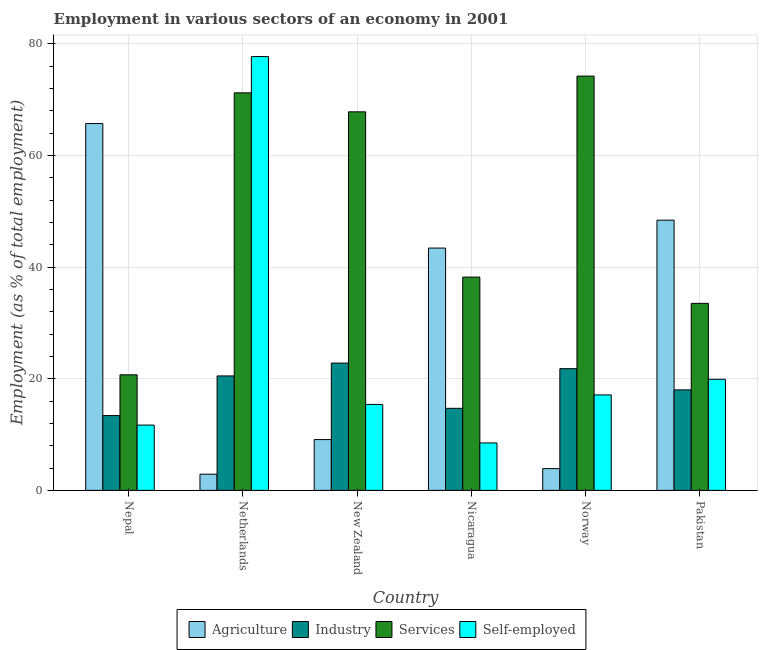How many groups of bars are there?
Make the answer very short. 6. Are the number of bars per tick equal to the number of legend labels?
Offer a very short reply. Yes. Are the number of bars on each tick of the X-axis equal?
Provide a succinct answer. Yes. How many bars are there on the 1st tick from the right?
Your response must be concise. 4. In how many cases, is the number of bars for a given country not equal to the number of legend labels?
Make the answer very short. 0. What is the percentage of workers in agriculture in Nepal?
Provide a succinct answer. 65.7. Across all countries, what is the maximum percentage of workers in agriculture?
Provide a short and direct response. 65.7. Across all countries, what is the minimum percentage of workers in agriculture?
Your response must be concise. 2.9. In which country was the percentage of workers in agriculture maximum?
Provide a short and direct response. Nepal. In which country was the percentage of workers in services minimum?
Make the answer very short. Nepal. What is the total percentage of workers in services in the graph?
Offer a terse response. 305.6. What is the difference between the percentage of workers in agriculture in Netherlands and that in Nicaragua?
Keep it short and to the point. -40.5. What is the difference between the percentage of self employed workers in Netherlands and the percentage of workers in services in Nepal?
Give a very brief answer. 57. What is the average percentage of workers in services per country?
Your response must be concise. 50.93. What is the difference between the percentage of workers in industry and percentage of workers in services in Netherlands?
Keep it short and to the point. -50.7. In how many countries, is the percentage of workers in services greater than 56 %?
Offer a very short reply. 3. What is the ratio of the percentage of workers in industry in Nepal to that in Norway?
Offer a terse response. 0.61. Is the percentage of workers in agriculture in New Zealand less than that in Norway?
Provide a short and direct response. No. Is the difference between the percentage of workers in services in Netherlands and Nicaragua greater than the difference between the percentage of workers in industry in Netherlands and Nicaragua?
Make the answer very short. Yes. What is the difference between the highest and the second highest percentage of workers in services?
Keep it short and to the point. 3. What is the difference between the highest and the lowest percentage of workers in services?
Offer a very short reply. 53.5. In how many countries, is the percentage of workers in industry greater than the average percentage of workers in industry taken over all countries?
Offer a terse response. 3. Is the sum of the percentage of workers in industry in Nepal and Nicaragua greater than the maximum percentage of self employed workers across all countries?
Your response must be concise. No. What does the 1st bar from the left in Pakistan represents?
Provide a short and direct response. Agriculture. What does the 2nd bar from the right in Norway represents?
Provide a short and direct response. Services. How many bars are there?
Offer a very short reply. 24. Does the graph contain any zero values?
Make the answer very short. No. Does the graph contain grids?
Provide a short and direct response. Yes. Where does the legend appear in the graph?
Your answer should be very brief. Bottom center. How many legend labels are there?
Provide a succinct answer. 4. What is the title of the graph?
Provide a short and direct response. Employment in various sectors of an economy in 2001. Does "Corruption" appear as one of the legend labels in the graph?
Your answer should be compact. No. What is the label or title of the X-axis?
Give a very brief answer. Country. What is the label or title of the Y-axis?
Offer a terse response. Employment (as % of total employment). What is the Employment (as % of total employment) of Agriculture in Nepal?
Make the answer very short. 65.7. What is the Employment (as % of total employment) of Industry in Nepal?
Your answer should be compact. 13.4. What is the Employment (as % of total employment) of Services in Nepal?
Make the answer very short. 20.7. What is the Employment (as % of total employment) in Self-employed in Nepal?
Provide a short and direct response. 11.7. What is the Employment (as % of total employment) of Agriculture in Netherlands?
Provide a succinct answer. 2.9. What is the Employment (as % of total employment) of Services in Netherlands?
Your answer should be very brief. 71.2. What is the Employment (as % of total employment) of Self-employed in Netherlands?
Provide a succinct answer. 77.7. What is the Employment (as % of total employment) in Agriculture in New Zealand?
Ensure brevity in your answer.  9.1. What is the Employment (as % of total employment) in Industry in New Zealand?
Offer a very short reply. 22.8. What is the Employment (as % of total employment) of Services in New Zealand?
Offer a very short reply. 67.8. What is the Employment (as % of total employment) in Self-employed in New Zealand?
Your answer should be compact. 15.4. What is the Employment (as % of total employment) in Agriculture in Nicaragua?
Your answer should be compact. 43.4. What is the Employment (as % of total employment) in Industry in Nicaragua?
Offer a very short reply. 14.7. What is the Employment (as % of total employment) in Services in Nicaragua?
Provide a short and direct response. 38.2. What is the Employment (as % of total employment) of Self-employed in Nicaragua?
Your answer should be very brief. 8.5. What is the Employment (as % of total employment) in Agriculture in Norway?
Ensure brevity in your answer.  3.9. What is the Employment (as % of total employment) in Industry in Norway?
Give a very brief answer. 21.8. What is the Employment (as % of total employment) of Services in Norway?
Give a very brief answer. 74.2. What is the Employment (as % of total employment) in Self-employed in Norway?
Ensure brevity in your answer.  17.1. What is the Employment (as % of total employment) of Agriculture in Pakistan?
Your response must be concise. 48.4. What is the Employment (as % of total employment) in Industry in Pakistan?
Keep it short and to the point. 18. What is the Employment (as % of total employment) of Services in Pakistan?
Make the answer very short. 33.5. What is the Employment (as % of total employment) of Self-employed in Pakistan?
Your response must be concise. 19.9. Across all countries, what is the maximum Employment (as % of total employment) in Agriculture?
Provide a short and direct response. 65.7. Across all countries, what is the maximum Employment (as % of total employment) in Industry?
Your answer should be compact. 22.8. Across all countries, what is the maximum Employment (as % of total employment) in Services?
Your answer should be very brief. 74.2. Across all countries, what is the maximum Employment (as % of total employment) in Self-employed?
Your answer should be compact. 77.7. Across all countries, what is the minimum Employment (as % of total employment) in Agriculture?
Your answer should be compact. 2.9. Across all countries, what is the minimum Employment (as % of total employment) in Industry?
Offer a terse response. 13.4. Across all countries, what is the minimum Employment (as % of total employment) of Services?
Ensure brevity in your answer.  20.7. Across all countries, what is the minimum Employment (as % of total employment) in Self-employed?
Give a very brief answer. 8.5. What is the total Employment (as % of total employment) in Agriculture in the graph?
Offer a terse response. 173.4. What is the total Employment (as % of total employment) of Industry in the graph?
Make the answer very short. 111.2. What is the total Employment (as % of total employment) of Services in the graph?
Your answer should be compact. 305.6. What is the total Employment (as % of total employment) in Self-employed in the graph?
Offer a terse response. 150.3. What is the difference between the Employment (as % of total employment) in Agriculture in Nepal and that in Netherlands?
Offer a terse response. 62.8. What is the difference between the Employment (as % of total employment) in Services in Nepal and that in Netherlands?
Give a very brief answer. -50.5. What is the difference between the Employment (as % of total employment) of Self-employed in Nepal and that in Netherlands?
Your response must be concise. -66. What is the difference between the Employment (as % of total employment) in Agriculture in Nepal and that in New Zealand?
Make the answer very short. 56.6. What is the difference between the Employment (as % of total employment) of Services in Nepal and that in New Zealand?
Ensure brevity in your answer.  -47.1. What is the difference between the Employment (as % of total employment) of Self-employed in Nepal and that in New Zealand?
Keep it short and to the point. -3.7. What is the difference between the Employment (as % of total employment) in Agriculture in Nepal and that in Nicaragua?
Give a very brief answer. 22.3. What is the difference between the Employment (as % of total employment) of Services in Nepal and that in Nicaragua?
Offer a very short reply. -17.5. What is the difference between the Employment (as % of total employment) of Self-employed in Nepal and that in Nicaragua?
Provide a succinct answer. 3.2. What is the difference between the Employment (as % of total employment) in Agriculture in Nepal and that in Norway?
Make the answer very short. 61.8. What is the difference between the Employment (as % of total employment) of Services in Nepal and that in Norway?
Make the answer very short. -53.5. What is the difference between the Employment (as % of total employment) in Self-employed in Nepal and that in Norway?
Offer a very short reply. -5.4. What is the difference between the Employment (as % of total employment) of Industry in Nepal and that in Pakistan?
Your response must be concise. -4.6. What is the difference between the Employment (as % of total employment) in Services in Nepal and that in Pakistan?
Your answer should be very brief. -12.8. What is the difference between the Employment (as % of total employment) in Self-employed in Nepal and that in Pakistan?
Offer a very short reply. -8.2. What is the difference between the Employment (as % of total employment) in Agriculture in Netherlands and that in New Zealand?
Your answer should be compact. -6.2. What is the difference between the Employment (as % of total employment) in Industry in Netherlands and that in New Zealand?
Keep it short and to the point. -2.3. What is the difference between the Employment (as % of total employment) of Self-employed in Netherlands and that in New Zealand?
Make the answer very short. 62.3. What is the difference between the Employment (as % of total employment) in Agriculture in Netherlands and that in Nicaragua?
Offer a terse response. -40.5. What is the difference between the Employment (as % of total employment) in Self-employed in Netherlands and that in Nicaragua?
Your response must be concise. 69.2. What is the difference between the Employment (as % of total employment) in Self-employed in Netherlands and that in Norway?
Provide a succinct answer. 60.6. What is the difference between the Employment (as % of total employment) of Agriculture in Netherlands and that in Pakistan?
Offer a very short reply. -45.5. What is the difference between the Employment (as % of total employment) in Industry in Netherlands and that in Pakistan?
Your answer should be compact. 2.5. What is the difference between the Employment (as % of total employment) of Services in Netherlands and that in Pakistan?
Offer a very short reply. 37.7. What is the difference between the Employment (as % of total employment) of Self-employed in Netherlands and that in Pakistan?
Give a very brief answer. 57.8. What is the difference between the Employment (as % of total employment) of Agriculture in New Zealand and that in Nicaragua?
Ensure brevity in your answer.  -34.3. What is the difference between the Employment (as % of total employment) in Industry in New Zealand and that in Nicaragua?
Keep it short and to the point. 8.1. What is the difference between the Employment (as % of total employment) of Services in New Zealand and that in Nicaragua?
Your answer should be very brief. 29.6. What is the difference between the Employment (as % of total employment) of Self-employed in New Zealand and that in Nicaragua?
Offer a terse response. 6.9. What is the difference between the Employment (as % of total employment) in Self-employed in New Zealand and that in Norway?
Provide a succinct answer. -1.7. What is the difference between the Employment (as % of total employment) of Agriculture in New Zealand and that in Pakistan?
Your response must be concise. -39.3. What is the difference between the Employment (as % of total employment) in Industry in New Zealand and that in Pakistan?
Your answer should be compact. 4.8. What is the difference between the Employment (as % of total employment) of Services in New Zealand and that in Pakistan?
Offer a terse response. 34.3. What is the difference between the Employment (as % of total employment) in Self-employed in New Zealand and that in Pakistan?
Your answer should be compact. -4.5. What is the difference between the Employment (as % of total employment) of Agriculture in Nicaragua and that in Norway?
Provide a short and direct response. 39.5. What is the difference between the Employment (as % of total employment) of Services in Nicaragua and that in Norway?
Keep it short and to the point. -36. What is the difference between the Employment (as % of total employment) of Industry in Nicaragua and that in Pakistan?
Keep it short and to the point. -3.3. What is the difference between the Employment (as % of total employment) in Agriculture in Norway and that in Pakistan?
Your answer should be compact. -44.5. What is the difference between the Employment (as % of total employment) of Industry in Norway and that in Pakistan?
Provide a succinct answer. 3.8. What is the difference between the Employment (as % of total employment) of Services in Norway and that in Pakistan?
Give a very brief answer. 40.7. What is the difference between the Employment (as % of total employment) in Self-employed in Norway and that in Pakistan?
Offer a very short reply. -2.8. What is the difference between the Employment (as % of total employment) of Agriculture in Nepal and the Employment (as % of total employment) of Industry in Netherlands?
Keep it short and to the point. 45.2. What is the difference between the Employment (as % of total employment) in Agriculture in Nepal and the Employment (as % of total employment) in Services in Netherlands?
Keep it short and to the point. -5.5. What is the difference between the Employment (as % of total employment) of Agriculture in Nepal and the Employment (as % of total employment) of Self-employed in Netherlands?
Offer a very short reply. -12. What is the difference between the Employment (as % of total employment) in Industry in Nepal and the Employment (as % of total employment) in Services in Netherlands?
Your answer should be very brief. -57.8. What is the difference between the Employment (as % of total employment) in Industry in Nepal and the Employment (as % of total employment) in Self-employed in Netherlands?
Ensure brevity in your answer.  -64.3. What is the difference between the Employment (as % of total employment) of Services in Nepal and the Employment (as % of total employment) of Self-employed in Netherlands?
Give a very brief answer. -57. What is the difference between the Employment (as % of total employment) in Agriculture in Nepal and the Employment (as % of total employment) in Industry in New Zealand?
Give a very brief answer. 42.9. What is the difference between the Employment (as % of total employment) in Agriculture in Nepal and the Employment (as % of total employment) in Self-employed in New Zealand?
Make the answer very short. 50.3. What is the difference between the Employment (as % of total employment) in Industry in Nepal and the Employment (as % of total employment) in Services in New Zealand?
Make the answer very short. -54.4. What is the difference between the Employment (as % of total employment) in Agriculture in Nepal and the Employment (as % of total employment) in Industry in Nicaragua?
Make the answer very short. 51. What is the difference between the Employment (as % of total employment) of Agriculture in Nepal and the Employment (as % of total employment) of Services in Nicaragua?
Keep it short and to the point. 27.5. What is the difference between the Employment (as % of total employment) in Agriculture in Nepal and the Employment (as % of total employment) in Self-employed in Nicaragua?
Your answer should be compact. 57.2. What is the difference between the Employment (as % of total employment) in Industry in Nepal and the Employment (as % of total employment) in Services in Nicaragua?
Provide a short and direct response. -24.8. What is the difference between the Employment (as % of total employment) of Industry in Nepal and the Employment (as % of total employment) of Self-employed in Nicaragua?
Give a very brief answer. 4.9. What is the difference between the Employment (as % of total employment) in Agriculture in Nepal and the Employment (as % of total employment) in Industry in Norway?
Keep it short and to the point. 43.9. What is the difference between the Employment (as % of total employment) in Agriculture in Nepal and the Employment (as % of total employment) in Services in Norway?
Your answer should be compact. -8.5. What is the difference between the Employment (as % of total employment) in Agriculture in Nepal and the Employment (as % of total employment) in Self-employed in Norway?
Make the answer very short. 48.6. What is the difference between the Employment (as % of total employment) of Industry in Nepal and the Employment (as % of total employment) of Services in Norway?
Provide a short and direct response. -60.8. What is the difference between the Employment (as % of total employment) of Agriculture in Nepal and the Employment (as % of total employment) of Industry in Pakistan?
Offer a very short reply. 47.7. What is the difference between the Employment (as % of total employment) in Agriculture in Nepal and the Employment (as % of total employment) in Services in Pakistan?
Ensure brevity in your answer.  32.2. What is the difference between the Employment (as % of total employment) of Agriculture in Nepal and the Employment (as % of total employment) of Self-employed in Pakistan?
Offer a terse response. 45.8. What is the difference between the Employment (as % of total employment) in Industry in Nepal and the Employment (as % of total employment) in Services in Pakistan?
Your answer should be compact. -20.1. What is the difference between the Employment (as % of total employment) in Agriculture in Netherlands and the Employment (as % of total employment) in Industry in New Zealand?
Your answer should be compact. -19.9. What is the difference between the Employment (as % of total employment) of Agriculture in Netherlands and the Employment (as % of total employment) of Services in New Zealand?
Keep it short and to the point. -64.9. What is the difference between the Employment (as % of total employment) of Industry in Netherlands and the Employment (as % of total employment) of Services in New Zealand?
Ensure brevity in your answer.  -47.3. What is the difference between the Employment (as % of total employment) in Industry in Netherlands and the Employment (as % of total employment) in Self-employed in New Zealand?
Keep it short and to the point. 5.1. What is the difference between the Employment (as % of total employment) of Services in Netherlands and the Employment (as % of total employment) of Self-employed in New Zealand?
Provide a succinct answer. 55.8. What is the difference between the Employment (as % of total employment) in Agriculture in Netherlands and the Employment (as % of total employment) in Industry in Nicaragua?
Ensure brevity in your answer.  -11.8. What is the difference between the Employment (as % of total employment) in Agriculture in Netherlands and the Employment (as % of total employment) in Services in Nicaragua?
Offer a terse response. -35.3. What is the difference between the Employment (as % of total employment) of Agriculture in Netherlands and the Employment (as % of total employment) of Self-employed in Nicaragua?
Give a very brief answer. -5.6. What is the difference between the Employment (as % of total employment) of Industry in Netherlands and the Employment (as % of total employment) of Services in Nicaragua?
Offer a terse response. -17.7. What is the difference between the Employment (as % of total employment) of Industry in Netherlands and the Employment (as % of total employment) of Self-employed in Nicaragua?
Your answer should be compact. 12. What is the difference between the Employment (as % of total employment) in Services in Netherlands and the Employment (as % of total employment) in Self-employed in Nicaragua?
Your response must be concise. 62.7. What is the difference between the Employment (as % of total employment) in Agriculture in Netherlands and the Employment (as % of total employment) in Industry in Norway?
Ensure brevity in your answer.  -18.9. What is the difference between the Employment (as % of total employment) in Agriculture in Netherlands and the Employment (as % of total employment) in Services in Norway?
Offer a very short reply. -71.3. What is the difference between the Employment (as % of total employment) of Agriculture in Netherlands and the Employment (as % of total employment) of Self-employed in Norway?
Provide a short and direct response. -14.2. What is the difference between the Employment (as % of total employment) in Industry in Netherlands and the Employment (as % of total employment) in Services in Norway?
Offer a very short reply. -53.7. What is the difference between the Employment (as % of total employment) in Industry in Netherlands and the Employment (as % of total employment) in Self-employed in Norway?
Offer a terse response. 3.4. What is the difference between the Employment (as % of total employment) of Services in Netherlands and the Employment (as % of total employment) of Self-employed in Norway?
Make the answer very short. 54.1. What is the difference between the Employment (as % of total employment) of Agriculture in Netherlands and the Employment (as % of total employment) of Industry in Pakistan?
Give a very brief answer. -15.1. What is the difference between the Employment (as % of total employment) in Agriculture in Netherlands and the Employment (as % of total employment) in Services in Pakistan?
Provide a succinct answer. -30.6. What is the difference between the Employment (as % of total employment) in Services in Netherlands and the Employment (as % of total employment) in Self-employed in Pakistan?
Provide a succinct answer. 51.3. What is the difference between the Employment (as % of total employment) of Agriculture in New Zealand and the Employment (as % of total employment) of Industry in Nicaragua?
Make the answer very short. -5.6. What is the difference between the Employment (as % of total employment) in Agriculture in New Zealand and the Employment (as % of total employment) in Services in Nicaragua?
Give a very brief answer. -29.1. What is the difference between the Employment (as % of total employment) in Industry in New Zealand and the Employment (as % of total employment) in Services in Nicaragua?
Your answer should be very brief. -15.4. What is the difference between the Employment (as % of total employment) of Services in New Zealand and the Employment (as % of total employment) of Self-employed in Nicaragua?
Your answer should be very brief. 59.3. What is the difference between the Employment (as % of total employment) of Agriculture in New Zealand and the Employment (as % of total employment) of Industry in Norway?
Offer a terse response. -12.7. What is the difference between the Employment (as % of total employment) in Agriculture in New Zealand and the Employment (as % of total employment) in Services in Norway?
Provide a short and direct response. -65.1. What is the difference between the Employment (as % of total employment) in Agriculture in New Zealand and the Employment (as % of total employment) in Self-employed in Norway?
Ensure brevity in your answer.  -8. What is the difference between the Employment (as % of total employment) of Industry in New Zealand and the Employment (as % of total employment) of Services in Norway?
Provide a succinct answer. -51.4. What is the difference between the Employment (as % of total employment) in Industry in New Zealand and the Employment (as % of total employment) in Self-employed in Norway?
Provide a short and direct response. 5.7. What is the difference between the Employment (as % of total employment) in Services in New Zealand and the Employment (as % of total employment) in Self-employed in Norway?
Your answer should be compact. 50.7. What is the difference between the Employment (as % of total employment) of Agriculture in New Zealand and the Employment (as % of total employment) of Industry in Pakistan?
Your answer should be compact. -8.9. What is the difference between the Employment (as % of total employment) of Agriculture in New Zealand and the Employment (as % of total employment) of Services in Pakistan?
Your answer should be very brief. -24.4. What is the difference between the Employment (as % of total employment) of Agriculture in New Zealand and the Employment (as % of total employment) of Self-employed in Pakistan?
Provide a short and direct response. -10.8. What is the difference between the Employment (as % of total employment) in Industry in New Zealand and the Employment (as % of total employment) in Self-employed in Pakistan?
Ensure brevity in your answer.  2.9. What is the difference between the Employment (as % of total employment) in Services in New Zealand and the Employment (as % of total employment) in Self-employed in Pakistan?
Your answer should be very brief. 47.9. What is the difference between the Employment (as % of total employment) of Agriculture in Nicaragua and the Employment (as % of total employment) of Industry in Norway?
Your response must be concise. 21.6. What is the difference between the Employment (as % of total employment) of Agriculture in Nicaragua and the Employment (as % of total employment) of Services in Norway?
Your answer should be very brief. -30.8. What is the difference between the Employment (as % of total employment) of Agriculture in Nicaragua and the Employment (as % of total employment) of Self-employed in Norway?
Your answer should be very brief. 26.3. What is the difference between the Employment (as % of total employment) in Industry in Nicaragua and the Employment (as % of total employment) in Services in Norway?
Give a very brief answer. -59.5. What is the difference between the Employment (as % of total employment) in Services in Nicaragua and the Employment (as % of total employment) in Self-employed in Norway?
Offer a terse response. 21.1. What is the difference between the Employment (as % of total employment) in Agriculture in Nicaragua and the Employment (as % of total employment) in Industry in Pakistan?
Provide a succinct answer. 25.4. What is the difference between the Employment (as % of total employment) in Industry in Nicaragua and the Employment (as % of total employment) in Services in Pakistan?
Your answer should be compact. -18.8. What is the difference between the Employment (as % of total employment) in Services in Nicaragua and the Employment (as % of total employment) in Self-employed in Pakistan?
Give a very brief answer. 18.3. What is the difference between the Employment (as % of total employment) in Agriculture in Norway and the Employment (as % of total employment) in Industry in Pakistan?
Make the answer very short. -14.1. What is the difference between the Employment (as % of total employment) of Agriculture in Norway and the Employment (as % of total employment) of Services in Pakistan?
Your response must be concise. -29.6. What is the difference between the Employment (as % of total employment) in Agriculture in Norway and the Employment (as % of total employment) in Self-employed in Pakistan?
Provide a succinct answer. -16. What is the difference between the Employment (as % of total employment) in Industry in Norway and the Employment (as % of total employment) in Self-employed in Pakistan?
Your response must be concise. 1.9. What is the difference between the Employment (as % of total employment) in Services in Norway and the Employment (as % of total employment) in Self-employed in Pakistan?
Your answer should be very brief. 54.3. What is the average Employment (as % of total employment) in Agriculture per country?
Ensure brevity in your answer.  28.9. What is the average Employment (as % of total employment) in Industry per country?
Keep it short and to the point. 18.53. What is the average Employment (as % of total employment) of Services per country?
Your answer should be compact. 50.93. What is the average Employment (as % of total employment) in Self-employed per country?
Provide a succinct answer. 25.05. What is the difference between the Employment (as % of total employment) of Agriculture and Employment (as % of total employment) of Industry in Nepal?
Make the answer very short. 52.3. What is the difference between the Employment (as % of total employment) of Agriculture and Employment (as % of total employment) of Services in Nepal?
Give a very brief answer. 45. What is the difference between the Employment (as % of total employment) in Agriculture and Employment (as % of total employment) in Self-employed in Nepal?
Give a very brief answer. 54. What is the difference between the Employment (as % of total employment) of Industry and Employment (as % of total employment) of Self-employed in Nepal?
Offer a terse response. 1.7. What is the difference between the Employment (as % of total employment) of Services and Employment (as % of total employment) of Self-employed in Nepal?
Provide a succinct answer. 9. What is the difference between the Employment (as % of total employment) in Agriculture and Employment (as % of total employment) in Industry in Netherlands?
Your response must be concise. -17.6. What is the difference between the Employment (as % of total employment) of Agriculture and Employment (as % of total employment) of Services in Netherlands?
Give a very brief answer. -68.3. What is the difference between the Employment (as % of total employment) of Agriculture and Employment (as % of total employment) of Self-employed in Netherlands?
Your answer should be compact. -74.8. What is the difference between the Employment (as % of total employment) of Industry and Employment (as % of total employment) of Services in Netherlands?
Give a very brief answer. -50.7. What is the difference between the Employment (as % of total employment) of Industry and Employment (as % of total employment) of Self-employed in Netherlands?
Keep it short and to the point. -57.2. What is the difference between the Employment (as % of total employment) of Services and Employment (as % of total employment) of Self-employed in Netherlands?
Your answer should be very brief. -6.5. What is the difference between the Employment (as % of total employment) in Agriculture and Employment (as % of total employment) in Industry in New Zealand?
Provide a short and direct response. -13.7. What is the difference between the Employment (as % of total employment) of Agriculture and Employment (as % of total employment) of Services in New Zealand?
Your response must be concise. -58.7. What is the difference between the Employment (as % of total employment) of Agriculture and Employment (as % of total employment) of Self-employed in New Zealand?
Give a very brief answer. -6.3. What is the difference between the Employment (as % of total employment) of Industry and Employment (as % of total employment) of Services in New Zealand?
Provide a short and direct response. -45. What is the difference between the Employment (as % of total employment) in Services and Employment (as % of total employment) in Self-employed in New Zealand?
Your response must be concise. 52.4. What is the difference between the Employment (as % of total employment) in Agriculture and Employment (as % of total employment) in Industry in Nicaragua?
Your answer should be compact. 28.7. What is the difference between the Employment (as % of total employment) of Agriculture and Employment (as % of total employment) of Services in Nicaragua?
Give a very brief answer. 5.2. What is the difference between the Employment (as % of total employment) of Agriculture and Employment (as % of total employment) of Self-employed in Nicaragua?
Your answer should be very brief. 34.9. What is the difference between the Employment (as % of total employment) in Industry and Employment (as % of total employment) in Services in Nicaragua?
Provide a succinct answer. -23.5. What is the difference between the Employment (as % of total employment) in Services and Employment (as % of total employment) in Self-employed in Nicaragua?
Ensure brevity in your answer.  29.7. What is the difference between the Employment (as % of total employment) of Agriculture and Employment (as % of total employment) of Industry in Norway?
Keep it short and to the point. -17.9. What is the difference between the Employment (as % of total employment) of Agriculture and Employment (as % of total employment) of Services in Norway?
Your response must be concise. -70.3. What is the difference between the Employment (as % of total employment) of Industry and Employment (as % of total employment) of Services in Norway?
Ensure brevity in your answer.  -52.4. What is the difference between the Employment (as % of total employment) of Industry and Employment (as % of total employment) of Self-employed in Norway?
Make the answer very short. 4.7. What is the difference between the Employment (as % of total employment) in Services and Employment (as % of total employment) in Self-employed in Norway?
Make the answer very short. 57.1. What is the difference between the Employment (as % of total employment) in Agriculture and Employment (as % of total employment) in Industry in Pakistan?
Offer a terse response. 30.4. What is the difference between the Employment (as % of total employment) in Agriculture and Employment (as % of total employment) in Self-employed in Pakistan?
Make the answer very short. 28.5. What is the difference between the Employment (as % of total employment) in Industry and Employment (as % of total employment) in Services in Pakistan?
Keep it short and to the point. -15.5. What is the difference between the Employment (as % of total employment) in Services and Employment (as % of total employment) in Self-employed in Pakistan?
Ensure brevity in your answer.  13.6. What is the ratio of the Employment (as % of total employment) of Agriculture in Nepal to that in Netherlands?
Provide a short and direct response. 22.66. What is the ratio of the Employment (as % of total employment) in Industry in Nepal to that in Netherlands?
Make the answer very short. 0.65. What is the ratio of the Employment (as % of total employment) of Services in Nepal to that in Netherlands?
Offer a very short reply. 0.29. What is the ratio of the Employment (as % of total employment) of Self-employed in Nepal to that in Netherlands?
Offer a terse response. 0.15. What is the ratio of the Employment (as % of total employment) of Agriculture in Nepal to that in New Zealand?
Your answer should be very brief. 7.22. What is the ratio of the Employment (as % of total employment) of Industry in Nepal to that in New Zealand?
Keep it short and to the point. 0.59. What is the ratio of the Employment (as % of total employment) in Services in Nepal to that in New Zealand?
Ensure brevity in your answer.  0.31. What is the ratio of the Employment (as % of total employment) of Self-employed in Nepal to that in New Zealand?
Your answer should be compact. 0.76. What is the ratio of the Employment (as % of total employment) in Agriculture in Nepal to that in Nicaragua?
Make the answer very short. 1.51. What is the ratio of the Employment (as % of total employment) of Industry in Nepal to that in Nicaragua?
Keep it short and to the point. 0.91. What is the ratio of the Employment (as % of total employment) in Services in Nepal to that in Nicaragua?
Your answer should be very brief. 0.54. What is the ratio of the Employment (as % of total employment) of Self-employed in Nepal to that in Nicaragua?
Offer a terse response. 1.38. What is the ratio of the Employment (as % of total employment) in Agriculture in Nepal to that in Norway?
Make the answer very short. 16.85. What is the ratio of the Employment (as % of total employment) of Industry in Nepal to that in Norway?
Keep it short and to the point. 0.61. What is the ratio of the Employment (as % of total employment) in Services in Nepal to that in Norway?
Make the answer very short. 0.28. What is the ratio of the Employment (as % of total employment) of Self-employed in Nepal to that in Norway?
Provide a short and direct response. 0.68. What is the ratio of the Employment (as % of total employment) in Agriculture in Nepal to that in Pakistan?
Offer a very short reply. 1.36. What is the ratio of the Employment (as % of total employment) in Industry in Nepal to that in Pakistan?
Your answer should be very brief. 0.74. What is the ratio of the Employment (as % of total employment) in Services in Nepal to that in Pakistan?
Make the answer very short. 0.62. What is the ratio of the Employment (as % of total employment) in Self-employed in Nepal to that in Pakistan?
Offer a very short reply. 0.59. What is the ratio of the Employment (as % of total employment) in Agriculture in Netherlands to that in New Zealand?
Your response must be concise. 0.32. What is the ratio of the Employment (as % of total employment) of Industry in Netherlands to that in New Zealand?
Make the answer very short. 0.9. What is the ratio of the Employment (as % of total employment) of Services in Netherlands to that in New Zealand?
Make the answer very short. 1.05. What is the ratio of the Employment (as % of total employment) in Self-employed in Netherlands to that in New Zealand?
Provide a succinct answer. 5.05. What is the ratio of the Employment (as % of total employment) of Agriculture in Netherlands to that in Nicaragua?
Your answer should be compact. 0.07. What is the ratio of the Employment (as % of total employment) in Industry in Netherlands to that in Nicaragua?
Your answer should be very brief. 1.39. What is the ratio of the Employment (as % of total employment) in Services in Netherlands to that in Nicaragua?
Keep it short and to the point. 1.86. What is the ratio of the Employment (as % of total employment) in Self-employed in Netherlands to that in Nicaragua?
Offer a very short reply. 9.14. What is the ratio of the Employment (as % of total employment) of Agriculture in Netherlands to that in Norway?
Ensure brevity in your answer.  0.74. What is the ratio of the Employment (as % of total employment) of Industry in Netherlands to that in Norway?
Your answer should be very brief. 0.94. What is the ratio of the Employment (as % of total employment) in Services in Netherlands to that in Norway?
Offer a very short reply. 0.96. What is the ratio of the Employment (as % of total employment) of Self-employed in Netherlands to that in Norway?
Your answer should be very brief. 4.54. What is the ratio of the Employment (as % of total employment) in Agriculture in Netherlands to that in Pakistan?
Offer a terse response. 0.06. What is the ratio of the Employment (as % of total employment) in Industry in Netherlands to that in Pakistan?
Ensure brevity in your answer.  1.14. What is the ratio of the Employment (as % of total employment) in Services in Netherlands to that in Pakistan?
Make the answer very short. 2.13. What is the ratio of the Employment (as % of total employment) of Self-employed in Netherlands to that in Pakistan?
Keep it short and to the point. 3.9. What is the ratio of the Employment (as % of total employment) of Agriculture in New Zealand to that in Nicaragua?
Keep it short and to the point. 0.21. What is the ratio of the Employment (as % of total employment) in Industry in New Zealand to that in Nicaragua?
Make the answer very short. 1.55. What is the ratio of the Employment (as % of total employment) in Services in New Zealand to that in Nicaragua?
Provide a short and direct response. 1.77. What is the ratio of the Employment (as % of total employment) in Self-employed in New Zealand to that in Nicaragua?
Offer a terse response. 1.81. What is the ratio of the Employment (as % of total employment) of Agriculture in New Zealand to that in Norway?
Offer a very short reply. 2.33. What is the ratio of the Employment (as % of total employment) in Industry in New Zealand to that in Norway?
Offer a very short reply. 1.05. What is the ratio of the Employment (as % of total employment) in Services in New Zealand to that in Norway?
Provide a short and direct response. 0.91. What is the ratio of the Employment (as % of total employment) of Self-employed in New Zealand to that in Norway?
Keep it short and to the point. 0.9. What is the ratio of the Employment (as % of total employment) of Agriculture in New Zealand to that in Pakistan?
Ensure brevity in your answer.  0.19. What is the ratio of the Employment (as % of total employment) in Industry in New Zealand to that in Pakistan?
Keep it short and to the point. 1.27. What is the ratio of the Employment (as % of total employment) of Services in New Zealand to that in Pakistan?
Keep it short and to the point. 2.02. What is the ratio of the Employment (as % of total employment) of Self-employed in New Zealand to that in Pakistan?
Offer a very short reply. 0.77. What is the ratio of the Employment (as % of total employment) of Agriculture in Nicaragua to that in Norway?
Give a very brief answer. 11.13. What is the ratio of the Employment (as % of total employment) in Industry in Nicaragua to that in Norway?
Provide a succinct answer. 0.67. What is the ratio of the Employment (as % of total employment) in Services in Nicaragua to that in Norway?
Give a very brief answer. 0.51. What is the ratio of the Employment (as % of total employment) in Self-employed in Nicaragua to that in Norway?
Make the answer very short. 0.5. What is the ratio of the Employment (as % of total employment) of Agriculture in Nicaragua to that in Pakistan?
Offer a terse response. 0.9. What is the ratio of the Employment (as % of total employment) of Industry in Nicaragua to that in Pakistan?
Provide a short and direct response. 0.82. What is the ratio of the Employment (as % of total employment) of Services in Nicaragua to that in Pakistan?
Provide a short and direct response. 1.14. What is the ratio of the Employment (as % of total employment) of Self-employed in Nicaragua to that in Pakistan?
Provide a short and direct response. 0.43. What is the ratio of the Employment (as % of total employment) in Agriculture in Norway to that in Pakistan?
Make the answer very short. 0.08. What is the ratio of the Employment (as % of total employment) of Industry in Norway to that in Pakistan?
Offer a very short reply. 1.21. What is the ratio of the Employment (as % of total employment) of Services in Norway to that in Pakistan?
Offer a very short reply. 2.21. What is the ratio of the Employment (as % of total employment) in Self-employed in Norway to that in Pakistan?
Offer a terse response. 0.86. What is the difference between the highest and the second highest Employment (as % of total employment) of Agriculture?
Your answer should be compact. 17.3. What is the difference between the highest and the second highest Employment (as % of total employment) in Industry?
Your response must be concise. 1. What is the difference between the highest and the second highest Employment (as % of total employment) in Self-employed?
Your response must be concise. 57.8. What is the difference between the highest and the lowest Employment (as % of total employment) of Agriculture?
Your answer should be very brief. 62.8. What is the difference between the highest and the lowest Employment (as % of total employment) of Industry?
Offer a terse response. 9.4. What is the difference between the highest and the lowest Employment (as % of total employment) in Services?
Make the answer very short. 53.5. What is the difference between the highest and the lowest Employment (as % of total employment) of Self-employed?
Provide a short and direct response. 69.2. 